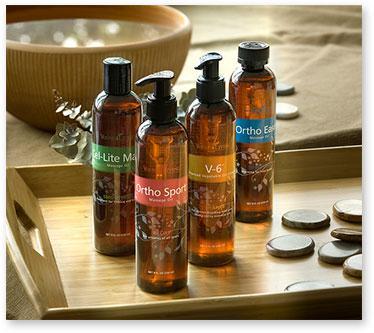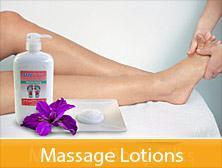The first image is the image on the left, the second image is the image on the right. Considering the images on both sides, is "There is a human body visible in one image." valid? Answer yes or no. Yes. The first image is the image on the left, the second image is the image on the right. Considering the images on both sides, is "Part of the human body is visible in one of the images." valid? Answer yes or no. Yes. 